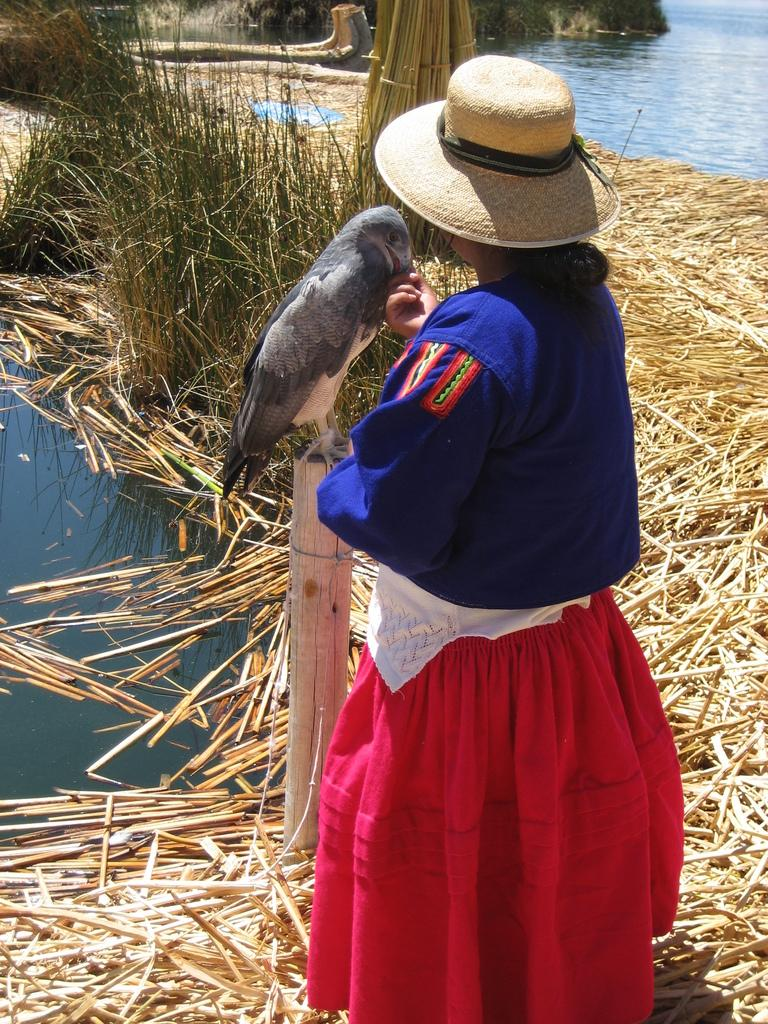What is the person in the image wearing on their head? The person is wearing a hat. What color is the shirt the person is wearing? The person is wearing a blue shirt. What color is the skirt the person is wearing? The person is wearing a red skirt. What can be seen on a wooden pole in the image? There is a bird on a wooden pole in the image. What type of natural elements can be seen in the image? There are dry twigs and plants visible in the image. What is the water in the image? There is water visible in the image. What type of cracker is the person holding in the image? There is no cracker present in the image. Can you see any ants crawling on the person's clothing in the image? There are no ants visible in the image. 